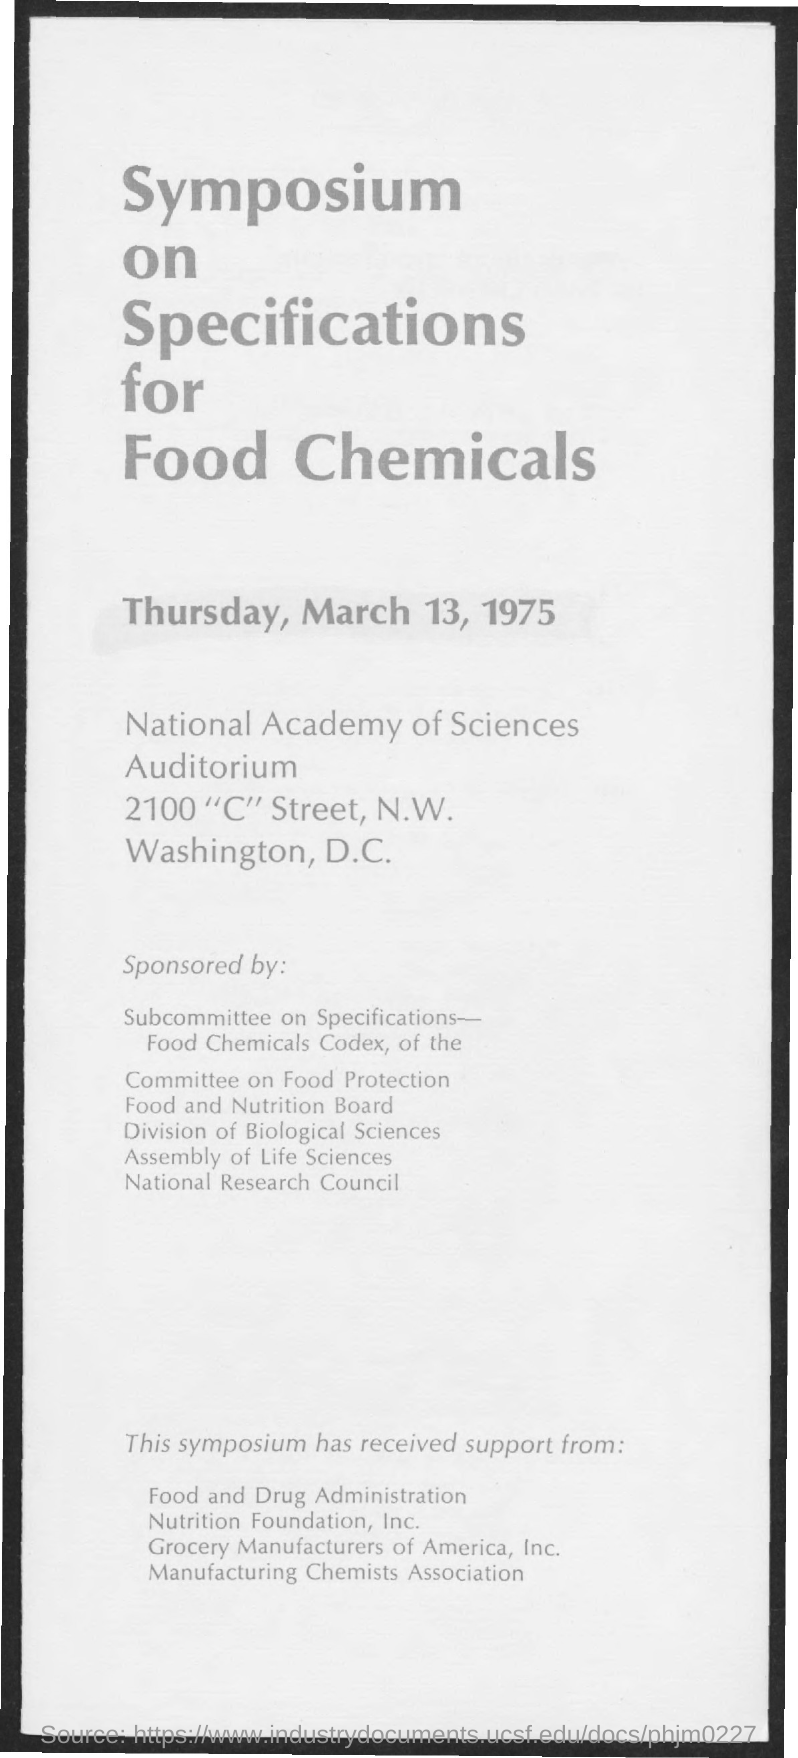Specify some key components in this picture. The date mentioned in the given page is Thursday, March 13, 1975. 